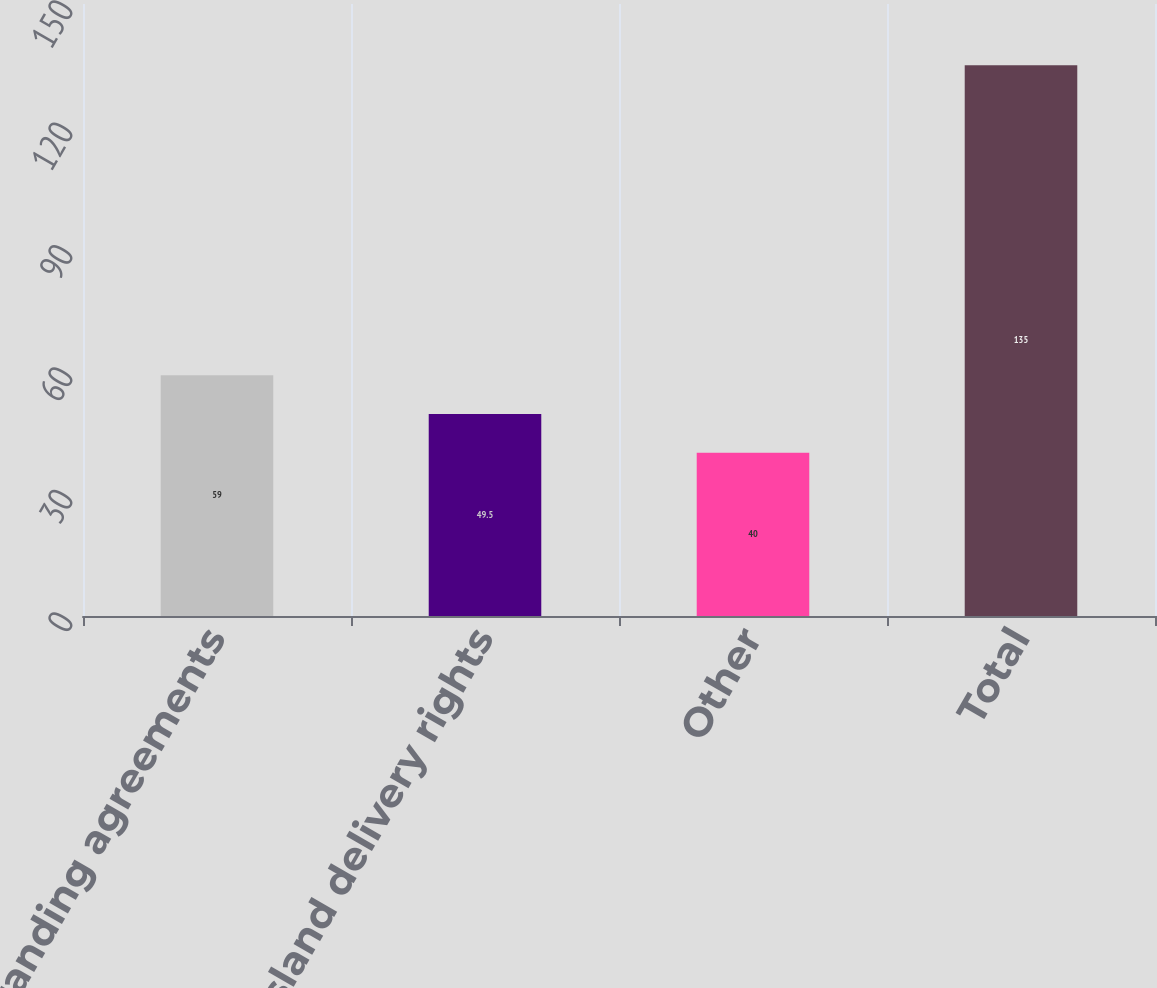Convert chart to OTSL. <chart><loc_0><loc_0><loc_500><loc_500><bar_chart><fcel>Branding agreements<fcel>Elba Island delivery rights<fcel>Other<fcel>Total<nl><fcel>59<fcel>49.5<fcel>40<fcel>135<nl></chart> 